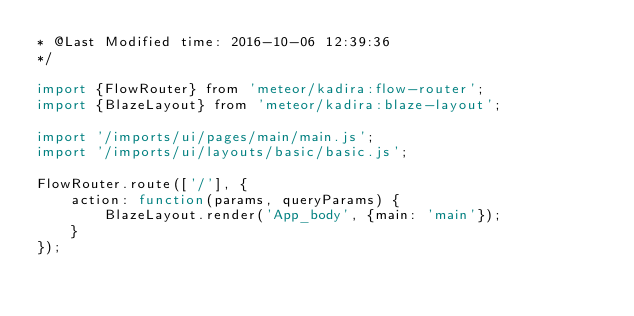<code> <loc_0><loc_0><loc_500><loc_500><_JavaScript_>* @Last Modified time: 2016-10-06 12:39:36
*/

import {FlowRouter} from 'meteor/kadira:flow-router';
import {BlazeLayout} from 'meteor/kadira:blaze-layout';

import '/imports/ui/pages/main/main.js';
import '/imports/ui/layouts/basic/basic.js';

FlowRouter.route(['/'], {
    action: function(params, queryParams) {
        BlazeLayout.render('App_body', {main: 'main'});
    }
});</code> 